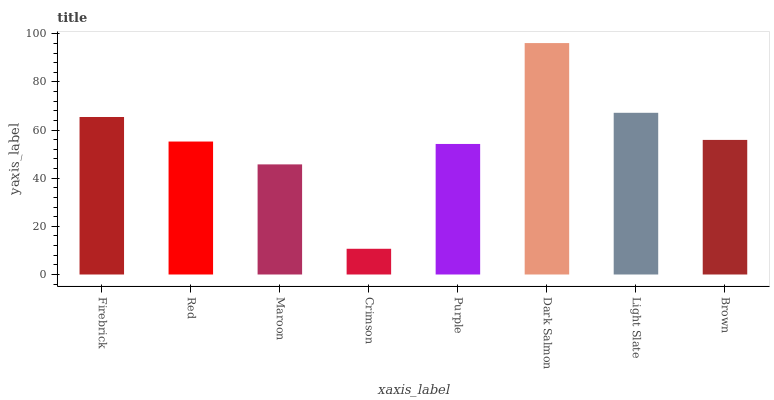Is Crimson the minimum?
Answer yes or no. Yes. Is Dark Salmon the maximum?
Answer yes or no. Yes. Is Red the minimum?
Answer yes or no. No. Is Red the maximum?
Answer yes or no. No. Is Firebrick greater than Red?
Answer yes or no. Yes. Is Red less than Firebrick?
Answer yes or no. Yes. Is Red greater than Firebrick?
Answer yes or no. No. Is Firebrick less than Red?
Answer yes or no. No. Is Brown the high median?
Answer yes or no. Yes. Is Red the low median?
Answer yes or no. Yes. Is Dark Salmon the high median?
Answer yes or no. No. Is Dark Salmon the low median?
Answer yes or no. No. 